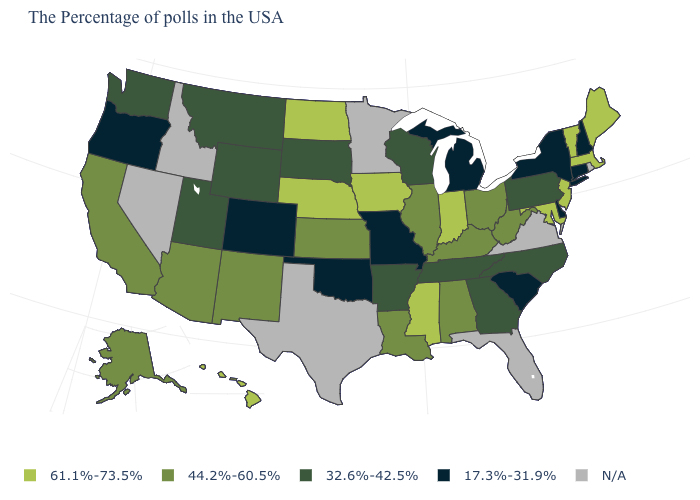Name the states that have a value in the range 17.3%-31.9%?
Be succinct. New Hampshire, Connecticut, New York, Delaware, South Carolina, Michigan, Missouri, Oklahoma, Colorado, Oregon. Is the legend a continuous bar?
Give a very brief answer. No. What is the value of West Virginia?
Short answer required. 44.2%-60.5%. Among the states that border California , which have the highest value?
Be succinct. Arizona. What is the highest value in states that border South Carolina?
Keep it brief. 32.6%-42.5%. Does the first symbol in the legend represent the smallest category?
Answer briefly. No. Among the states that border Louisiana , which have the highest value?
Concise answer only. Mississippi. Among the states that border Arkansas , which have the highest value?
Give a very brief answer. Mississippi. Which states hav the highest value in the MidWest?
Keep it brief. Indiana, Iowa, Nebraska, North Dakota. Among the states that border Massachusetts , does Vermont have the highest value?
Answer briefly. Yes. What is the value of North Carolina?
Be succinct. 32.6%-42.5%. Among the states that border Colorado , does Oklahoma have the lowest value?
Answer briefly. Yes. Name the states that have a value in the range 61.1%-73.5%?
Write a very short answer. Maine, Massachusetts, Vermont, New Jersey, Maryland, Indiana, Mississippi, Iowa, Nebraska, North Dakota, Hawaii. Which states have the highest value in the USA?
Concise answer only. Maine, Massachusetts, Vermont, New Jersey, Maryland, Indiana, Mississippi, Iowa, Nebraska, North Dakota, Hawaii. What is the highest value in the USA?
Answer briefly. 61.1%-73.5%. 